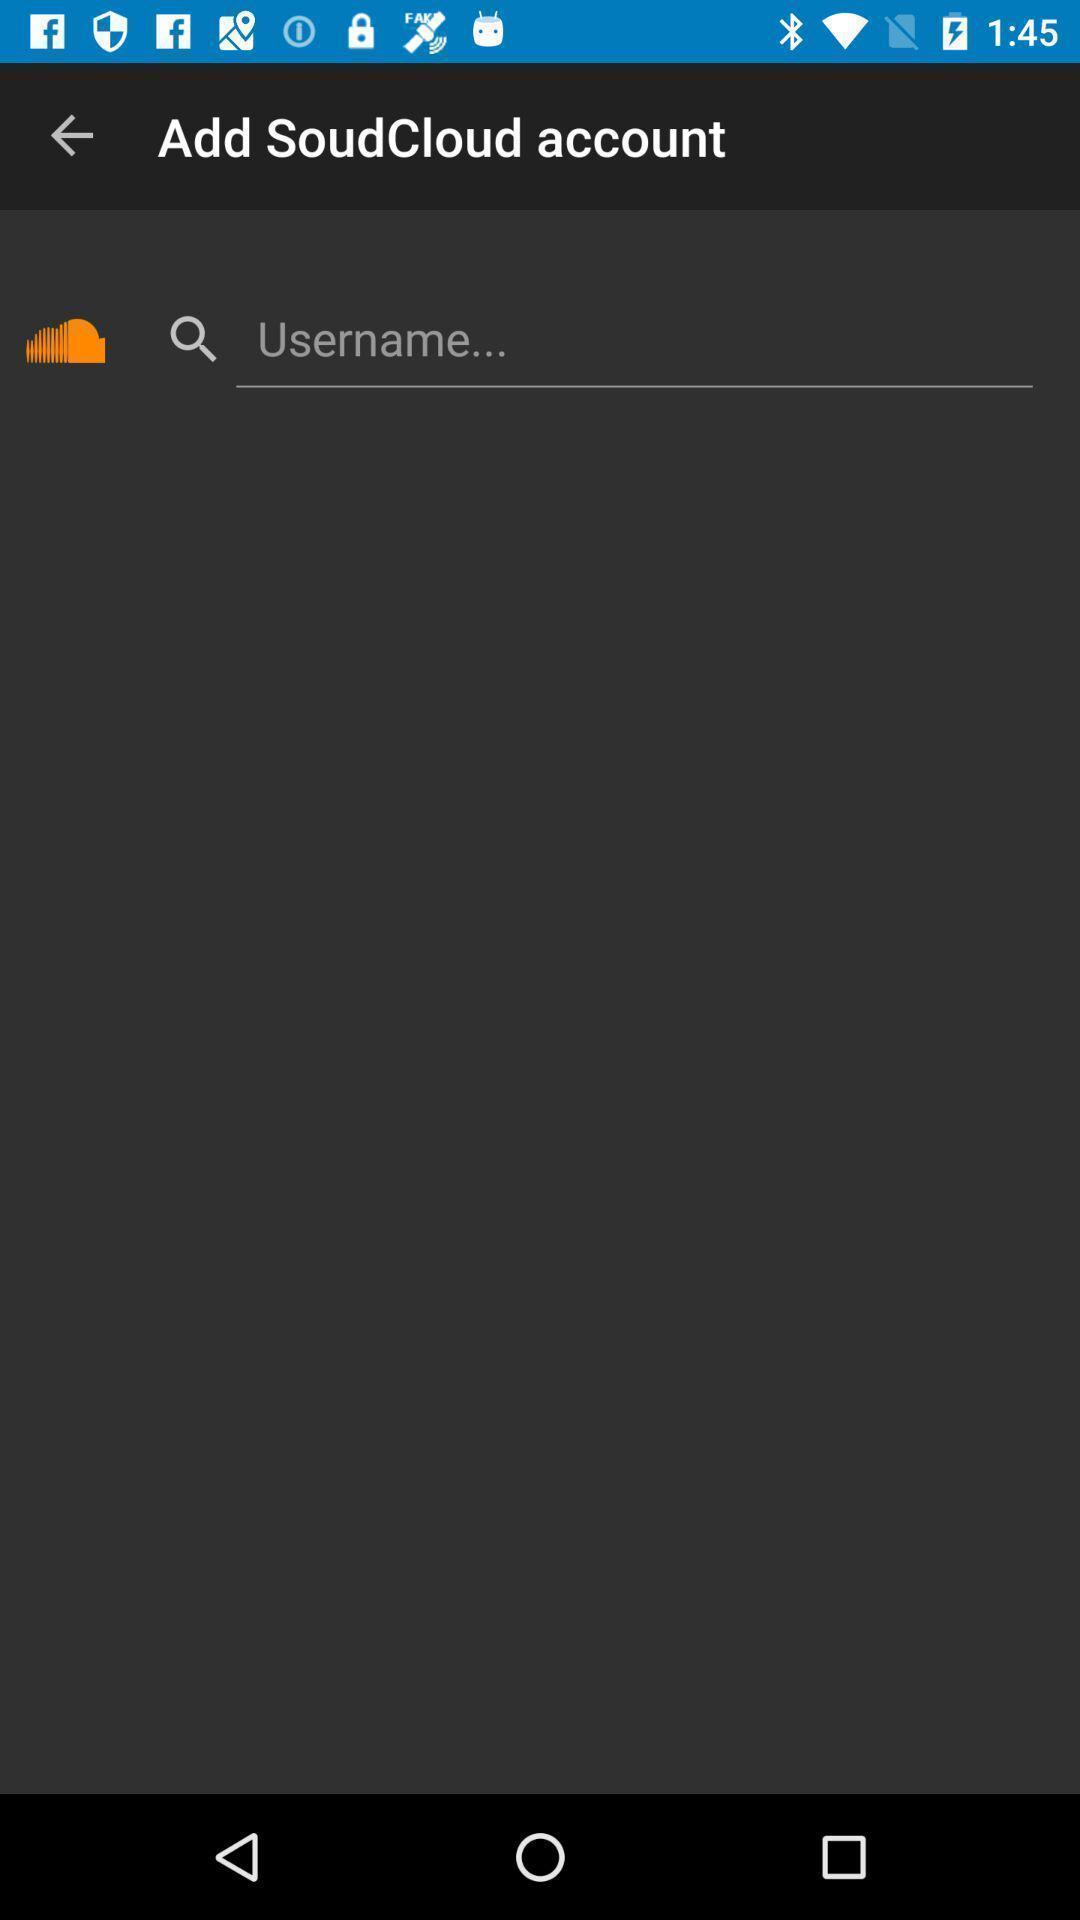Explain the elements present in this screenshot. Search bar to add a account. 